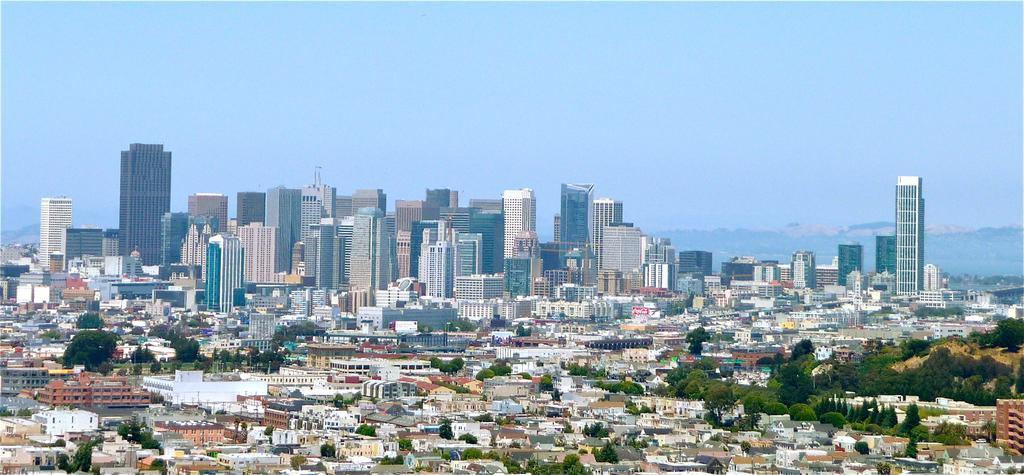In one or two sentences, can you explain what this image depicts? This picture is clicked outside. In the foreground we can see the trees and many number of houses. In the background we can see the sky, buildings and skyscrapers and many other objects. 